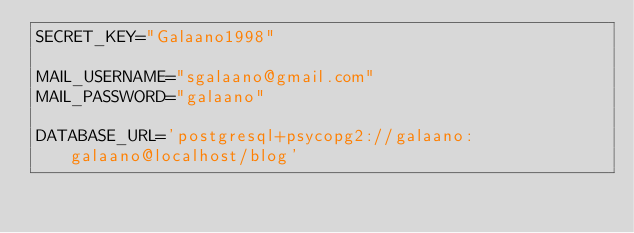Convert code to text. <code><loc_0><loc_0><loc_500><loc_500><_Python_>SECRET_KEY="Galaano1998"

MAIL_USERNAME="sgalaano@gmail.com"
MAIL_PASSWORD="galaano"

DATABASE_URL='postgresql+psycopg2://galaano:galaano@localhost/blog'
</code> 